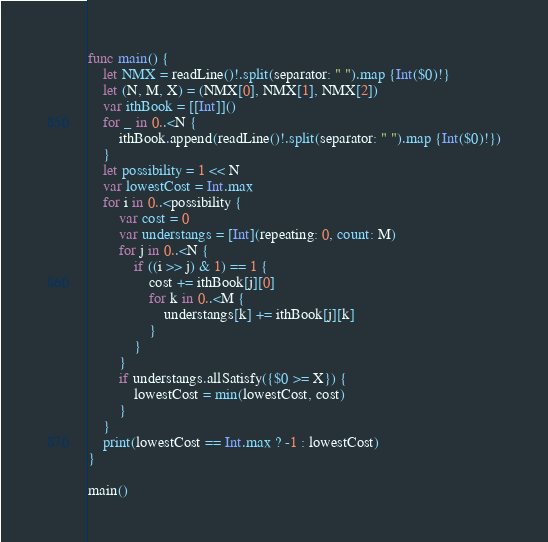<code> <loc_0><loc_0><loc_500><loc_500><_Swift_>func main() {
    let NMX = readLine()!.split(separator: " ").map {Int($0)!}
    let (N, M, X) = (NMX[0], NMX[1], NMX[2])
    var ithBook = [[Int]]()
    for _ in 0..<N {
        ithBook.append(readLine()!.split(separator: " ").map {Int($0)!})
    }
    let possibility = 1 << N
    var lowestCost = Int.max
    for i in 0..<possibility {
        var cost = 0
        var understangs = [Int](repeating: 0, count: M)
        for j in 0..<N {
            if ((i >> j) & 1) == 1 {
                cost += ithBook[j][0]
                for k in 0..<M {
                    understangs[k] += ithBook[j][k]
                }
            }
        }
        if understangs.allSatisfy({$0 >= X}) {
            lowestCost = min(lowestCost, cost)
        }
    }
    print(lowestCost == Int.max ? -1 : lowestCost)
}

main()
</code> 